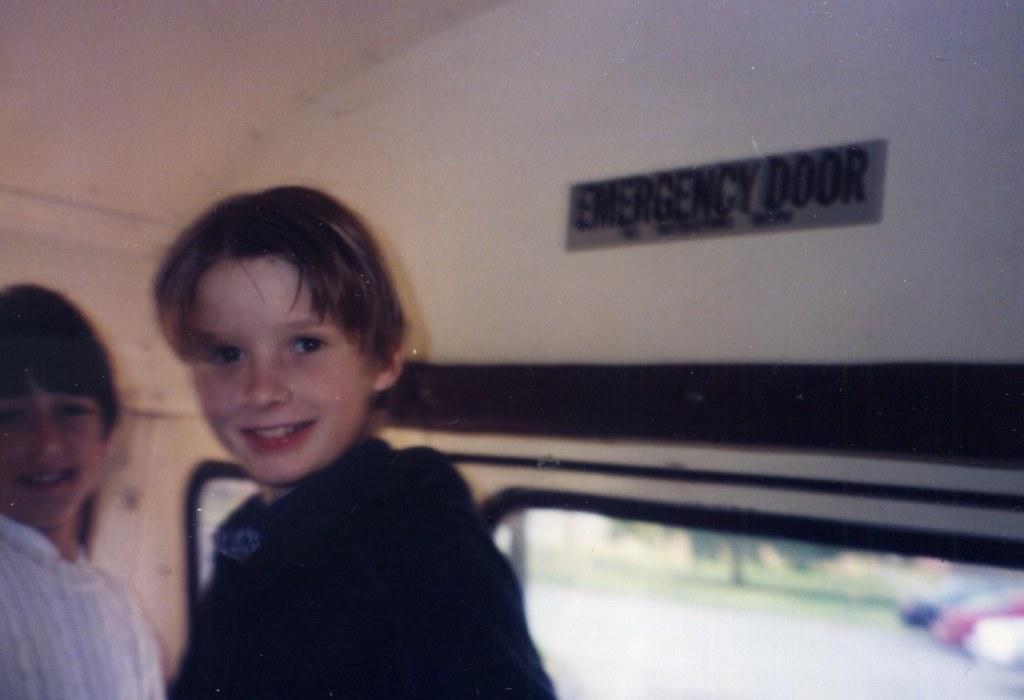Could you give a brief overview of what you see in this image? In the picture we can see a two children are standing near the emergency door with a glass and from it we can see surface with some cars are parked and a grass surface with a tree on it. 